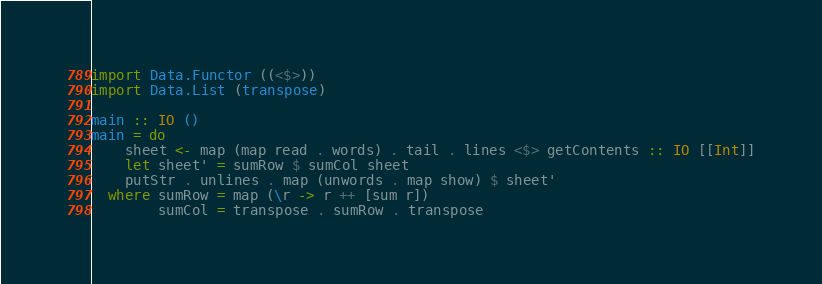<code> <loc_0><loc_0><loc_500><loc_500><_Haskell_>import Data.Functor ((<$>))
import Data.List (transpose)

main :: IO ()
main = do
    sheet <- map (map read . words) . tail . lines <$> getContents :: IO [[Int]]
    let sheet' = sumRow $ sumCol sheet
    putStr . unlines . map (unwords . map show) $ sheet'
  where sumRow = map (\r -> r ++ [sum r])
        sumCol = transpose . sumRow . transpose

</code> 